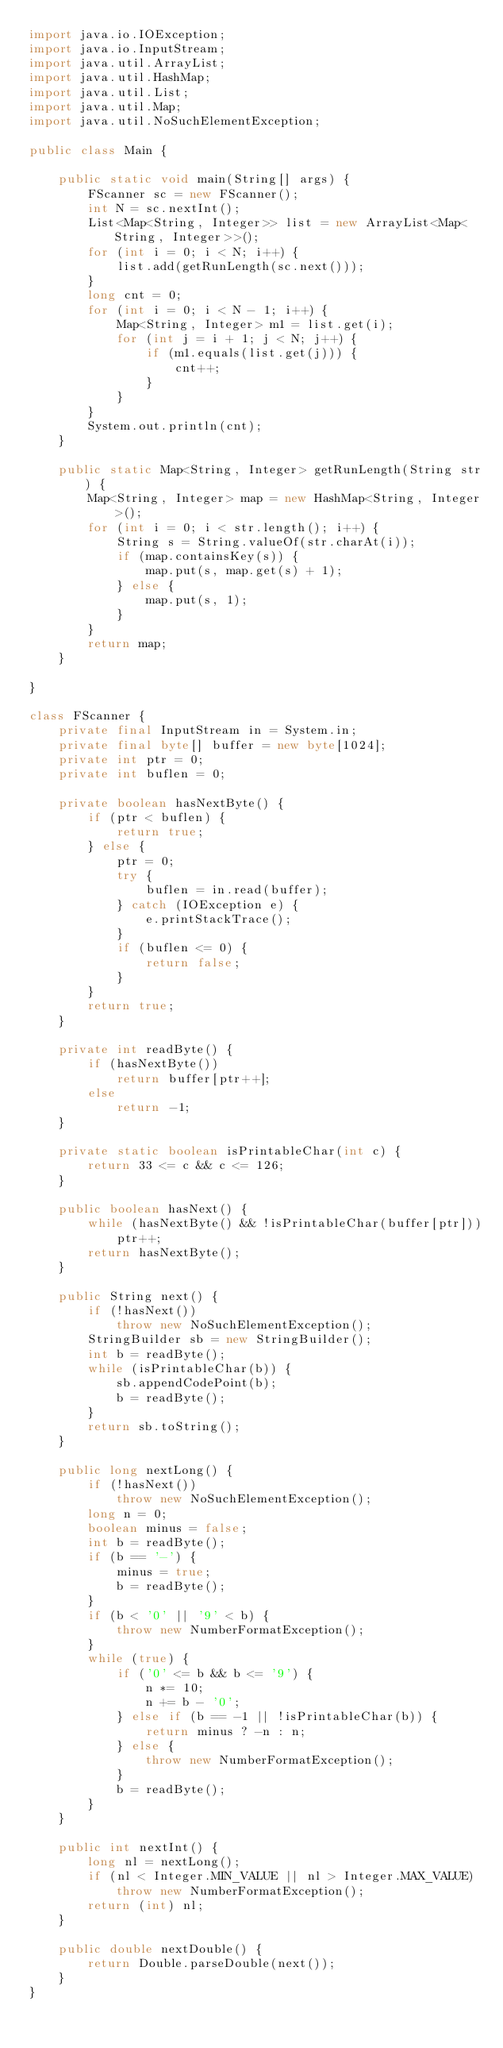Convert code to text. <code><loc_0><loc_0><loc_500><loc_500><_Java_>import java.io.IOException;
import java.io.InputStream;
import java.util.ArrayList;
import java.util.HashMap;
import java.util.List;
import java.util.Map;
import java.util.NoSuchElementException;

public class Main {

	public static void main(String[] args) {
		FScanner sc = new FScanner();
		int N = sc.nextInt();
		List<Map<String, Integer>> list = new ArrayList<Map<String, Integer>>();
		for (int i = 0; i < N; i++) {
			list.add(getRunLength(sc.next()));
		}
		long cnt = 0;
		for (int i = 0; i < N - 1; i++) {
			Map<String, Integer> m1 = list.get(i);
			for (int j = i + 1; j < N; j++) {
				if (m1.equals(list.get(j))) {
					cnt++;
				}
			}
		}
		System.out.println(cnt);
	}

	public static Map<String, Integer> getRunLength(String str) {
		Map<String, Integer> map = new HashMap<String, Integer>();
		for (int i = 0; i < str.length(); i++) {
			String s = String.valueOf(str.charAt(i));
			if (map.containsKey(s)) {
				map.put(s, map.get(s) + 1);
			} else {
				map.put(s, 1);
			}
		}
		return map;
	}

}

class FScanner {
	private final InputStream in = System.in;
	private final byte[] buffer = new byte[1024];
	private int ptr = 0;
	private int buflen = 0;

	private boolean hasNextByte() {
		if (ptr < buflen) {
			return true;
		} else {
			ptr = 0;
			try {
				buflen = in.read(buffer);
			} catch (IOException e) {
				e.printStackTrace();
			}
			if (buflen <= 0) {
				return false;
			}
		}
		return true;
	}

	private int readByte() {
		if (hasNextByte())
			return buffer[ptr++];
		else
			return -1;
	}

	private static boolean isPrintableChar(int c) {
		return 33 <= c && c <= 126;
	}

	public boolean hasNext() {
		while (hasNextByte() && !isPrintableChar(buffer[ptr]))
			ptr++;
		return hasNextByte();
	}

	public String next() {
		if (!hasNext())
			throw new NoSuchElementException();
		StringBuilder sb = new StringBuilder();
		int b = readByte();
		while (isPrintableChar(b)) {
			sb.appendCodePoint(b);
			b = readByte();
		}
		return sb.toString();
	}

	public long nextLong() {
		if (!hasNext())
			throw new NoSuchElementException();
		long n = 0;
		boolean minus = false;
		int b = readByte();
		if (b == '-') {
			minus = true;
			b = readByte();
		}
		if (b < '0' || '9' < b) {
			throw new NumberFormatException();
		}
		while (true) {
			if ('0' <= b && b <= '9') {
				n *= 10;
				n += b - '0';
			} else if (b == -1 || !isPrintableChar(b)) {
				return minus ? -n : n;
			} else {
				throw new NumberFormatException();
			}
			b = readByte();
		}
	}

	public int nextInt() {
		long nl = nextLong();
		if (nl < Integer.MIN_VALUE || nl > Integer.MAX_VALUE)
			throw new NumberFormatException();
		return (int) nl;
	}

	public double nextDouble() {
		return Double.parseDouble(next());
	}
}</code> 